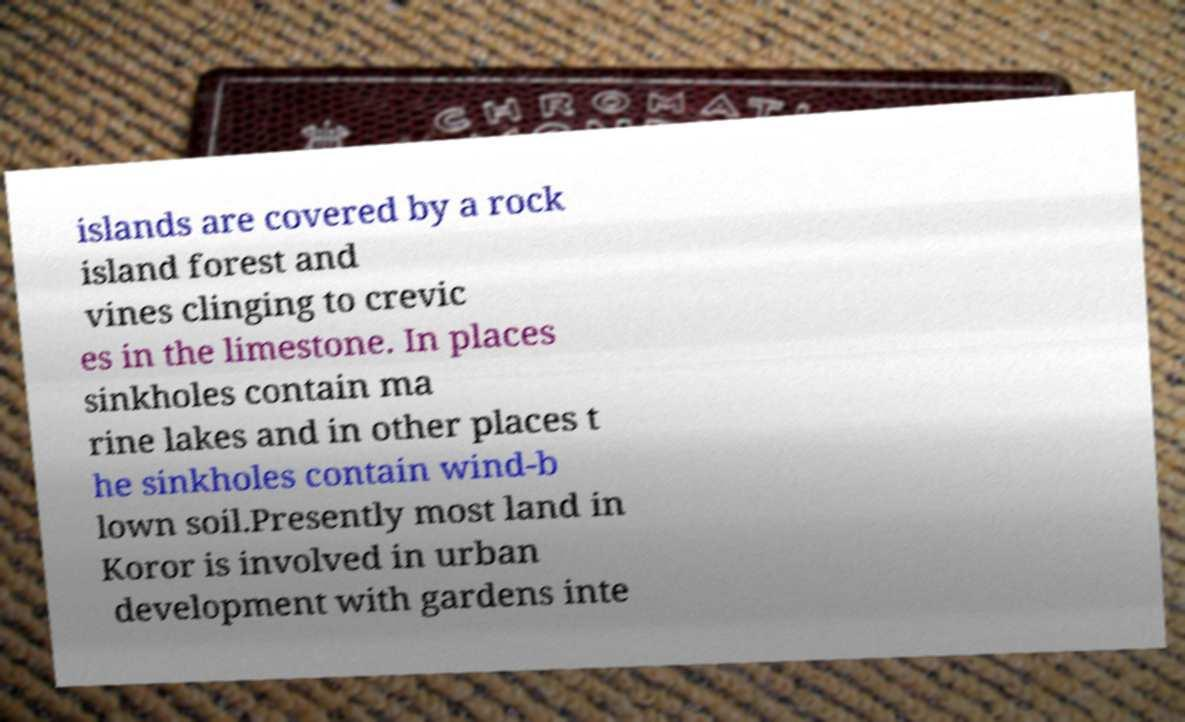For documentation purposes, I need the text within this image transcribed. Could you provide that? islands are covered by a rock island forest and vines clinging to crevic es in the limestone. In places sinkholes contain ma rine lakes and in other places t he sinkholes contain wind-b lown soil.Presently most land in Koror is involved in urban development with gardens inte 